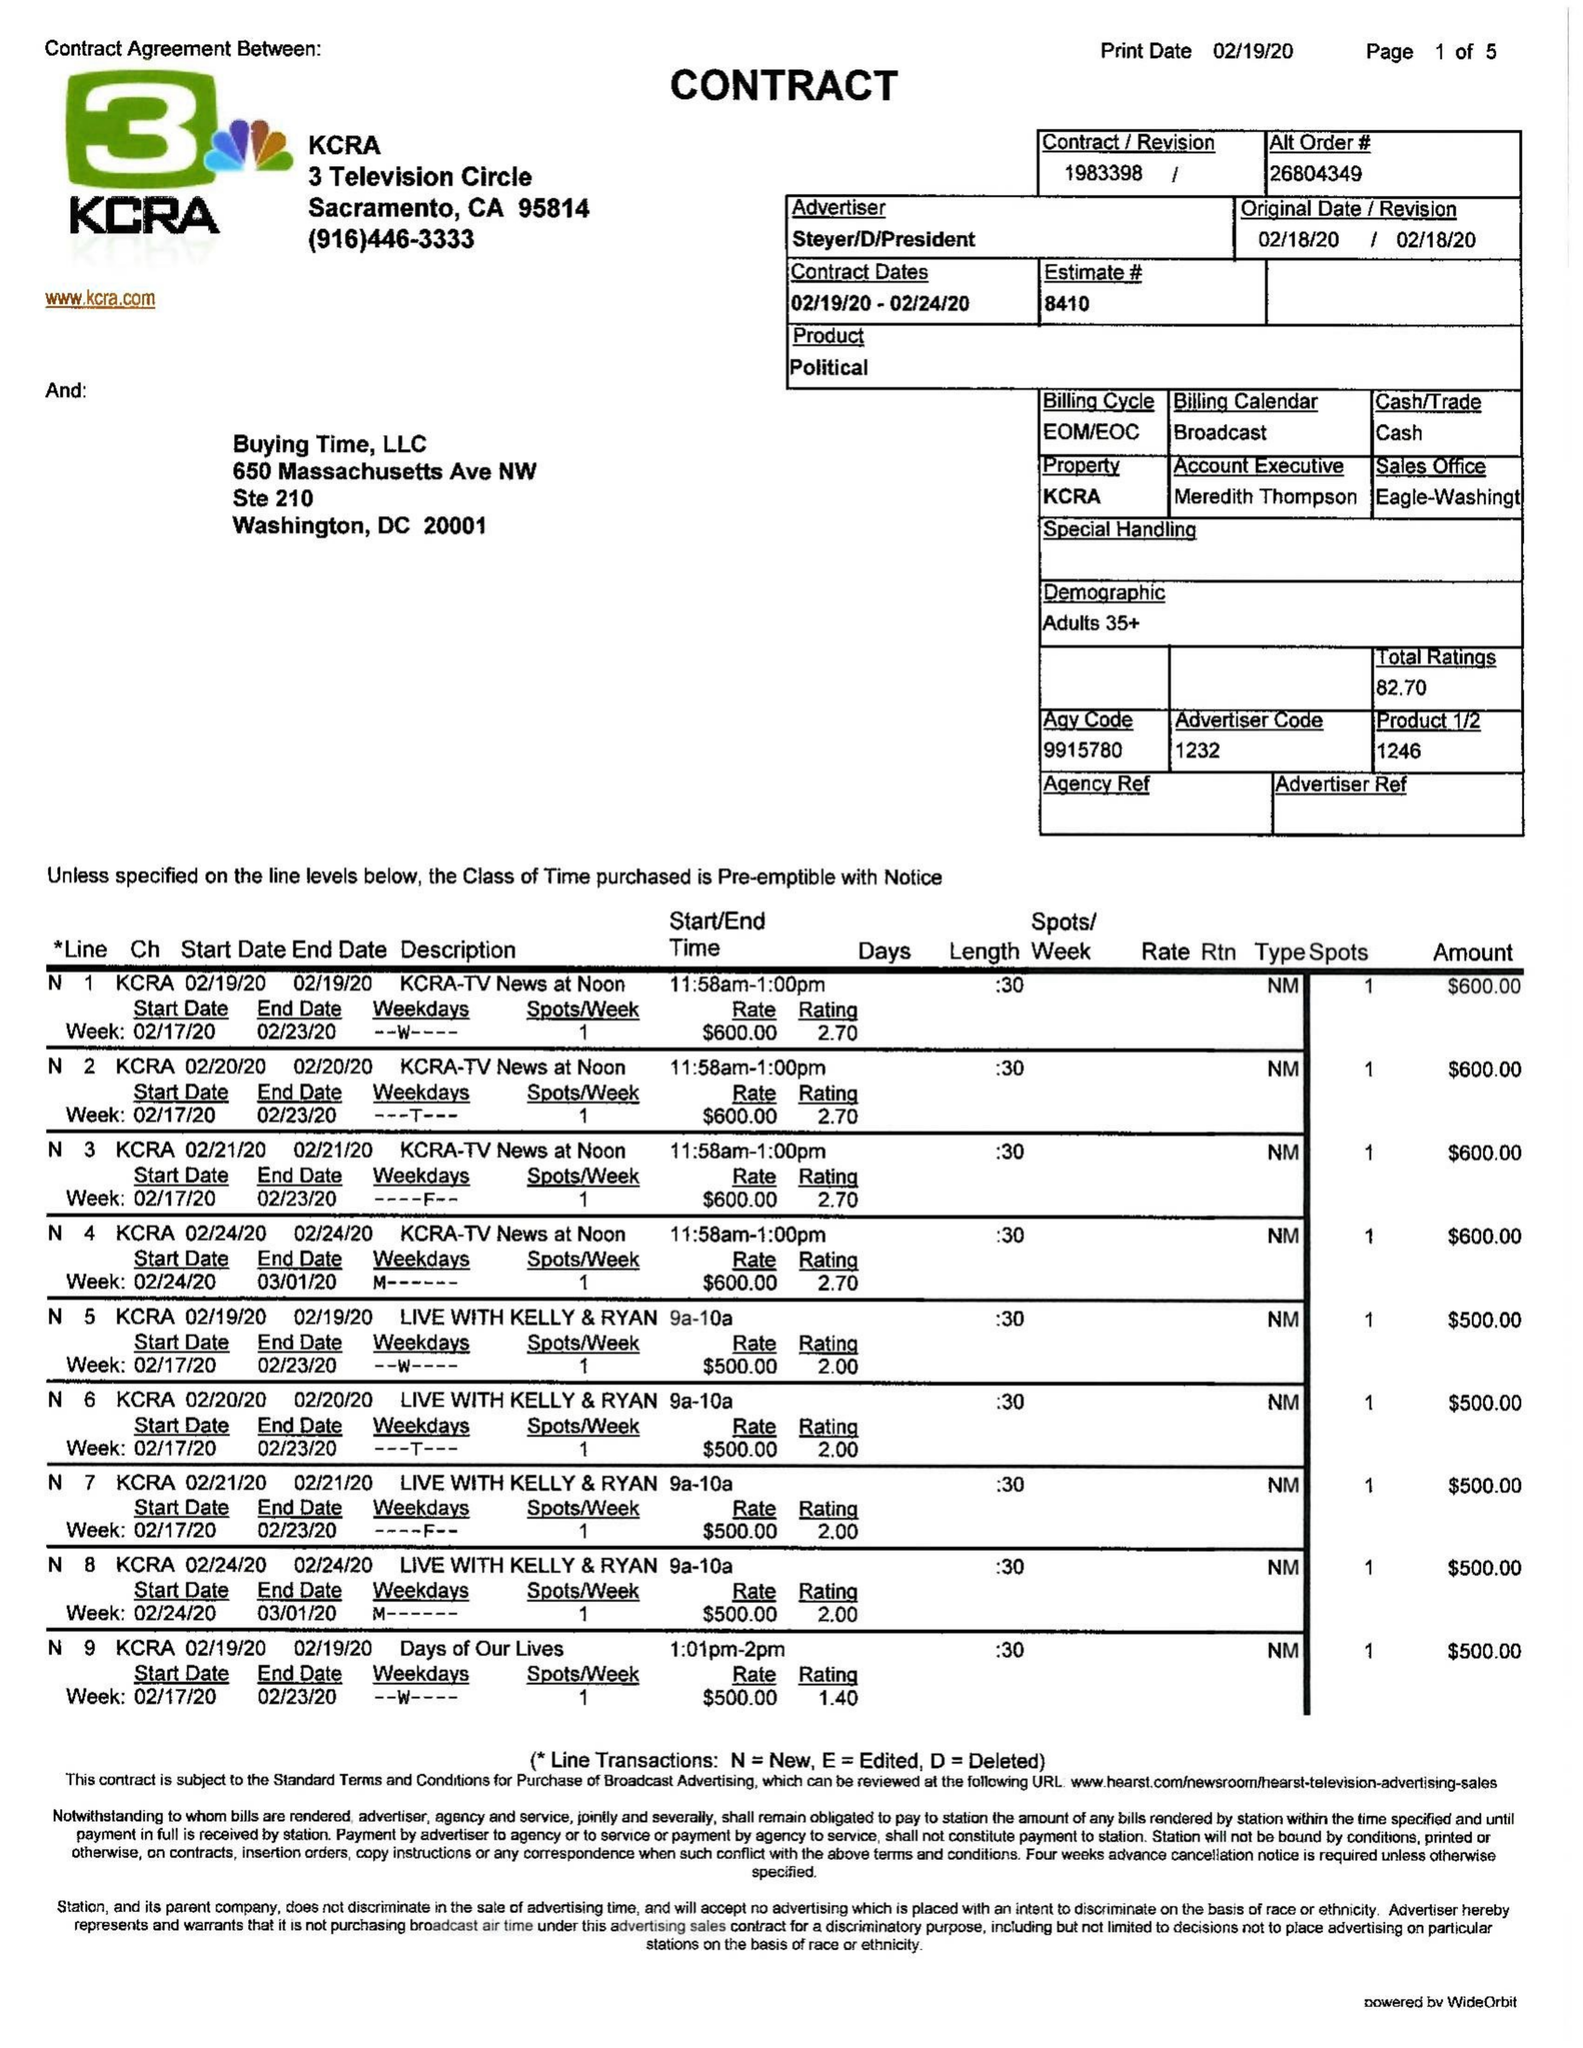What is the value for the flight_to?
Answer the question using a single word or phrase. 02/24/20 